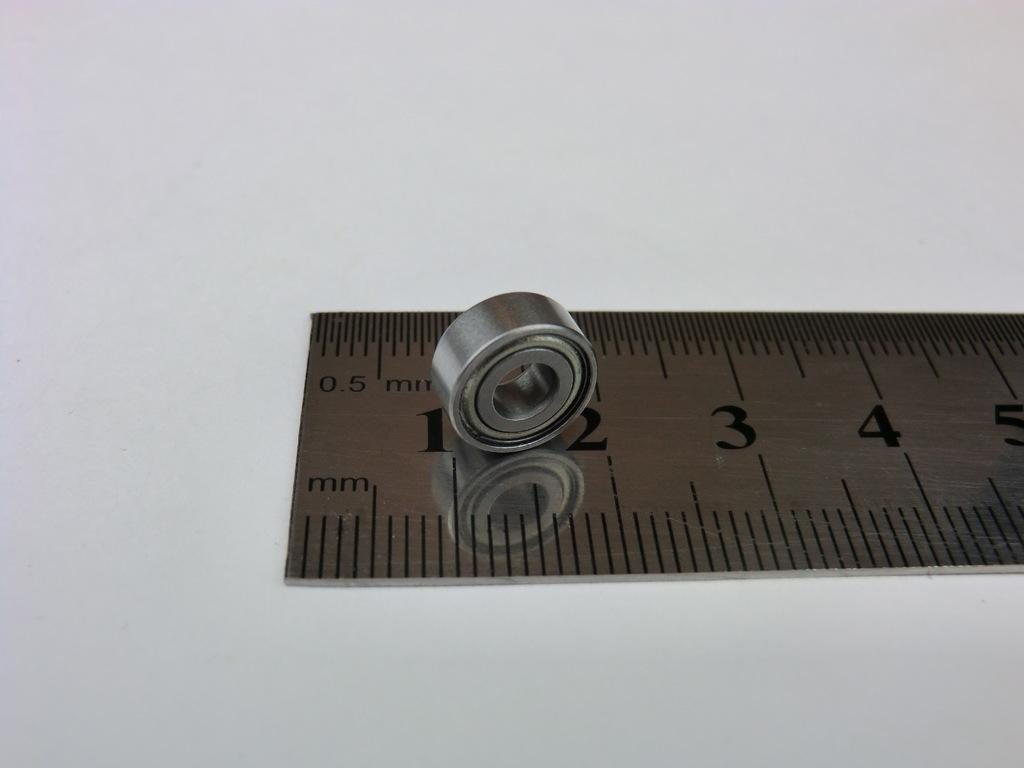<image>
Offer a succinct explanation of the picture presented. A ruler is measuring a bolt between the "1" and "2" mm mark. 